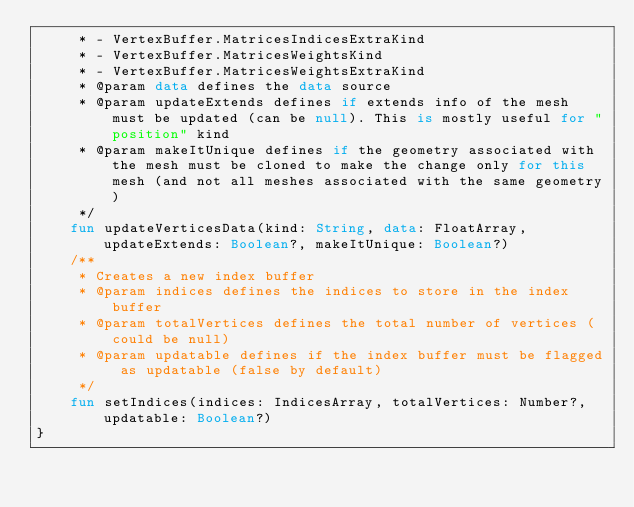Convert code to text. <code><loc_0><loc_0><loc_500><loc_500><_Kotlin_>     * - VertexBuffer.MatricesIndicesExtraKind
     * - VertexBuffer.MatricesWeightsKind
     * - VertexBuffer.MatricesWeightsExtraKind
     * @param data defines the data source
     * @param updateExtends defines if extends info of the mesh must be updated (can be null). This is mostly useful for "position" kind
     * @param makeItUnique defines if the geometry associated with the mesh must be cloned to make the change only for this mesh (and not all meshes associated with the same geometry)
     */
    fun updateVerticesData(kind: String, data: FloatArray, updateExtends: Boolean?, makeItUnique: Boolean?)
    /**
     * Creates a new index buffer
     * @param indices defines the indices to store in the index buffer
     * @param totalVertices defines the total number of vertices (could be null)
     * @param updatable defines if the index buffer must be flagged as updatable (false by default)
     */
    fun setIndices(indices: IndicesArray, totalVertices: Number?, updatable: Boolean?)
}
</code> 